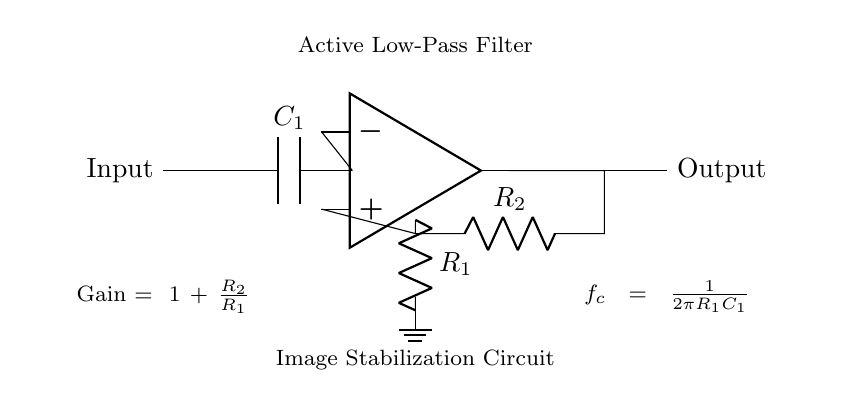What type of filter is present in this circuit? The circuit includes an active low-pass filter, as indicated by the label within the diagram. The filter design is typically used to allow low-frequency signals to pass while attenuating high-frequency signals.
Answer: active low-pass filter What components are used in this circuit? The components in the circuit are a capacitor (C1), two resistors (R1, R2), and an operational amplifier (op amp). These components work together to create the filtering effect necessary for image stabilization.
Answer: capacitor, resistors, op amp What is the relationship between R2 and the gain? The gain of the circuit is calculated using the formula that states Gain equals one plus the ratio of R2 to R1. Therefore, the value of R2 directly affects the gain of the filter circuit; increasing R2 increases the gain.
Answer: Gain equals one plus R2 over R1 What is the cutoff frequency formula? The circuit provides a specific formula for the cutoff frequency, denoted as f_c. This formula, f_c equals one over two pi times R1 times C1, defines the frequency at which the output voltage is reduced to 70.7% of its maximum value.
Answer: f_c equals one over two pi R1 C1 What is the purpose of the capacitor in this circuit? The capacitor C1 in the active low-pass filter serves to store and release electrical energy. It primarily affects the frequency response of the circuit by allowing low-frequency signals to pass while blocking higher frequencies, which is essential for image stabilization in low-light environments.
Answer: store and release electrical energy What happens to the output if R1 increases? If R1 increases, the cutoff frequency f_c decreases according to the formula provided in the circuit. This means that the filter will allow lower frequency signals to pass through while attenuating higher frequencies even more, thus improving image stabilization in low-light conditions.
Answer: cutoff frequency decreases What does the term "image stabilization circuit" refer to in this context? The term "image stabilization circuit" refers to the overall function of the active low-pass filter in the context of real-time image processing. It helps reduce any unwanted high-frequency noise in the image signals, allowing for clearer and more stable images when capturing photos in low light.
Answer: reduces high-frequency noise 